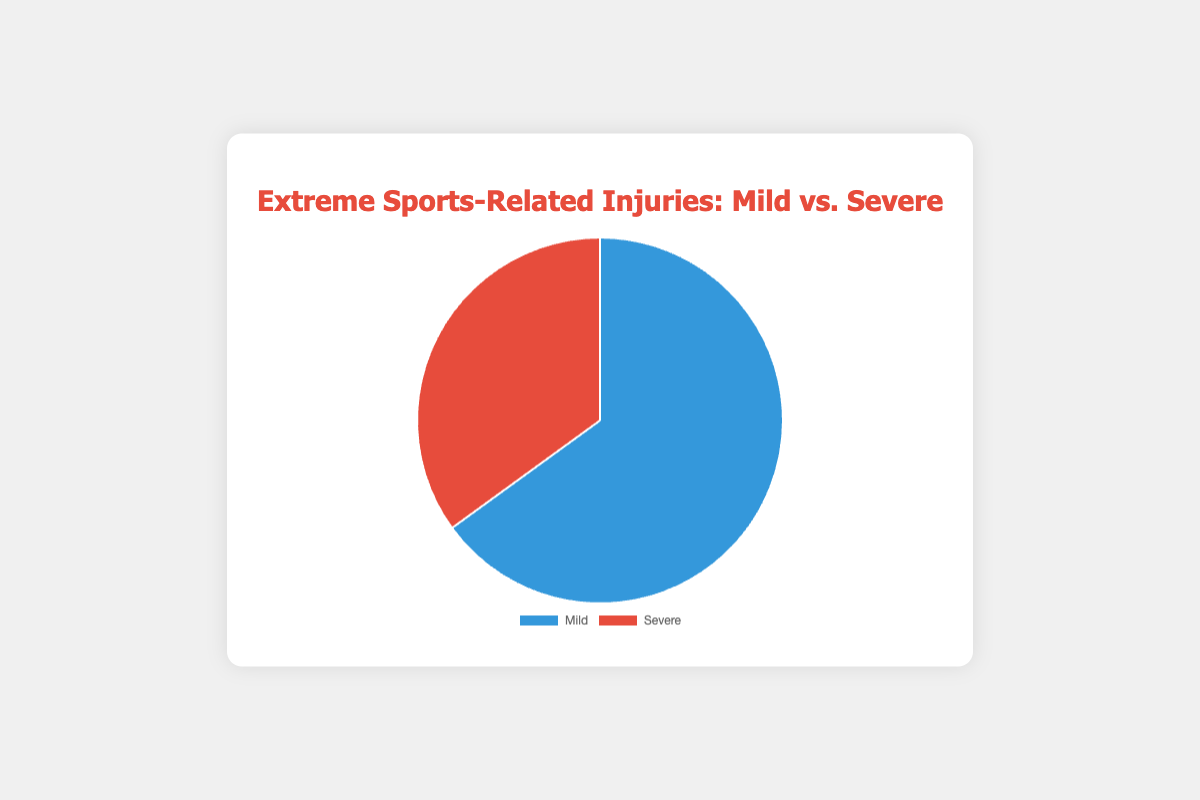What percentage of extreme sports-related injuries are mild? The pie chart displays that mild injuries constitute 65% of extreme sports-related injuries.
Answer: 65% What percentage of extreme sports-related injuries are severe? The pie chart shows that severe injuries comprise 35% of extreme sports-related injuries.
Answer: 35% Which type of extreme sports-related injury is more common, mild or severe? The pie chart indicates that mild injuries, at 65%, are more common than severe injuries, which are at 35%.
Answer: Mild How much higher is the percentage of mild injuries compared to severe injuries? The percentage of mild injuries is 65%, and the percentage of severe injuries is 35%. The difference is 65% - 35% = 30%.
Answer: 30% If we combine the percentages of mild and severe injuries, what is the total percentage? By adding the percentage of mild injuries (65%) to severe injuries (35%), we get 65% + 35% = 100%.
Answer: 100% What is the ratio of mild injuries to severe injuries? The ratio of mild injuries (65%) to severe injuries (35%) is calculated as 65:35. Simplifying this ratio by dividing both numbers by their greatest common divisor (5), we get 13:7.
Answer: 13:7 If there were 200 total extreme sports-related injuries, how many of these would you expect to be severe? Given that severe injuries constitute 35% of the total, we can find the expected number of severe injuries by calculating 35% of 200, which is (0.35 * 200) = 70 injuries.
Answer: 70 injuries What is the relative visual ratio of the blue section to the red section in the pie chart? The blue section represents mild injuries at 65%, and the red section represents severe injuries at 35%. The visual ratio can be observed as nearly 2:1, since 65 is almost double 35.
Answer: 2:1 